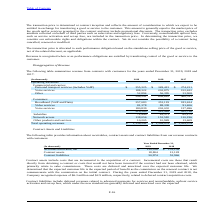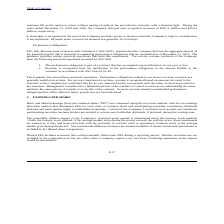According to Consolidated Communications Holdings's financial document, What was the expense recognized by the company in 2019? According to the financial document, $6.3 million. The relevant text states: ", 2019 and 2018, the Company recognized expense of $6.3 million and $2.9 million, respectively, related to deferred contract acquisition costs...." Also, What was the deferred and recognized revenue in 2019? According to the financial document, $397.5 million. The relevant text states: "8, the Company deferred and recognized revenues of $397.5 million and $354.2 million, respectively...." Also, What is the number of days for the payment terms on invoiced amounts? According to the financial document, 30 to 60 days. The relevant text states: ". Payment terms on invoiced amounts are generally 30 to 60 days...." Also, can you calculate: What is the accounts receivable, net increase / (decrease) from 2018 to 2019? Based on the calculation: 120,016 - 133,136, the result is -13120 (in thousands). This is based on the information: "Accounts receivable, net $ 120,016 $ 133,136 Accounts receivable, net $ 120,016 $ 133,136..." The key data points involved are: 120,016, 133,136. Also, can you calculate: What was the percentage increase / (decrease) in the contract assets from 2018 to 2019? To answer this question, I need to perform calculations using the financial data. The calculation is: 18,804 / 12,128 - 1, which equals 55.05 (percentage). This is based on the information: "Contract assets 18,804 12,128 Contract assets 18,804 12,128..." The key data points involved are: 12,128, 18,804. Also, can you calculate: What is the average contract liabilities for 2018 and 2019? To answer this question, I need to perform calculations using the financial data. The calculation is: (50,974 + 52,966) / 2, which equals 51970 (in thousands). This is based on the information: "Contract liabilities 50,974 52,966 Contract liabilities 50,974 52,966..." The key data points involved are: 50,974, 52,966. 